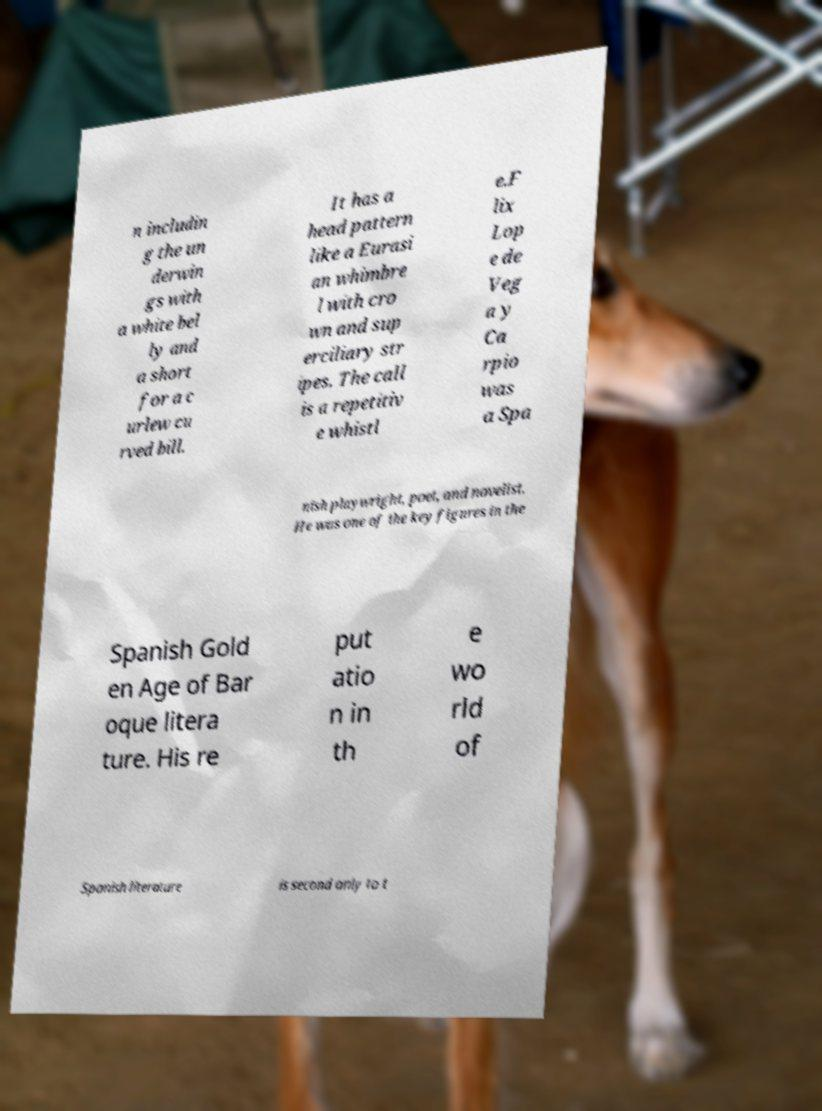What messages or text are displayed in this image? I need them in a readable, typed format. n includin g the un derwin gs with a white bel ly and a short for a c urlew cu rved bill. It has a head pattern like a Eurasi an whimbre l with cro wn and sup erciliary str ipes. The call is a repetitiv e whistl e.F lix Lop e de Veg a y Ca rpio was a Spa nish playwright, poet, and novelist. He was one of the key figures in the Spanish Gold en Age of Bar oque litera ture. His re put atio n in th e wo rld of Spanish literature is second only to t 